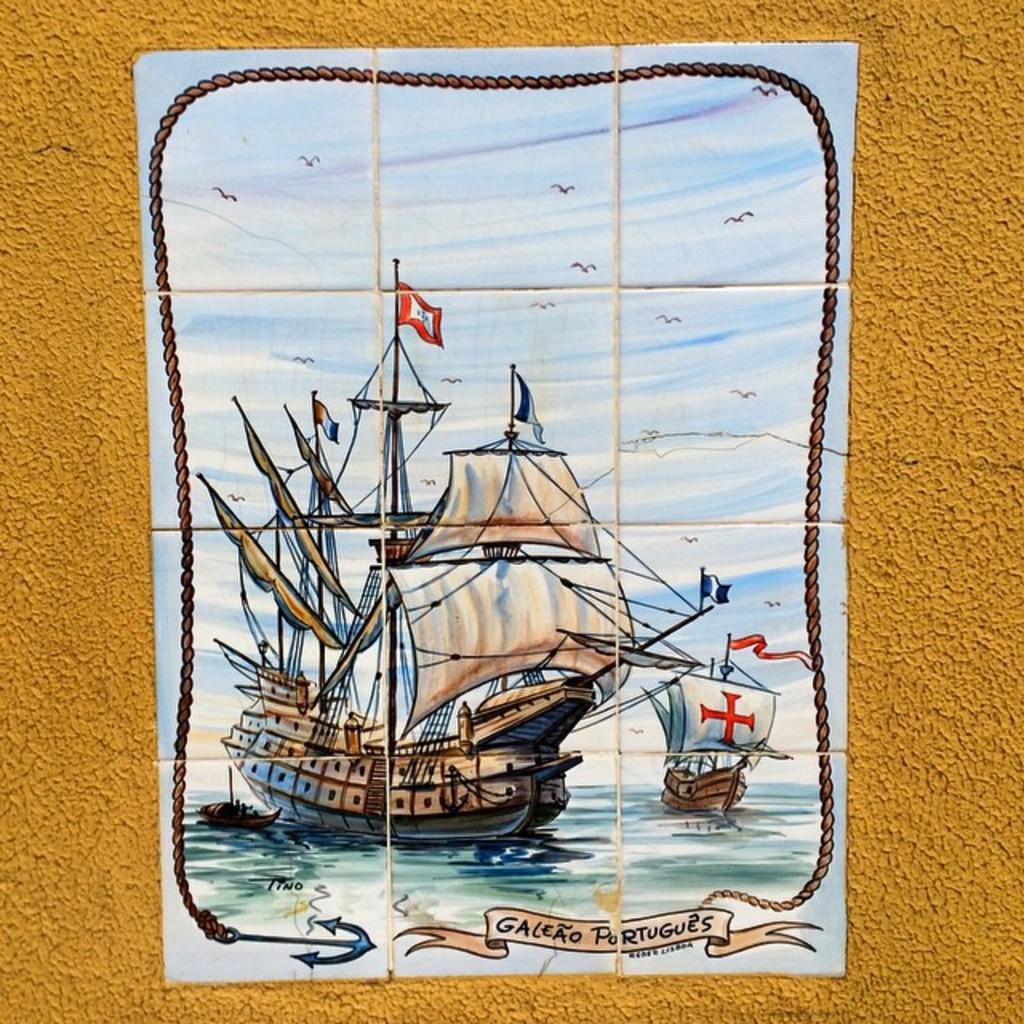What does the puzzle caption tell us?
Your answer should be very brief. Galeao portugues. Did tino paint and sign this above the anchor?
Your response must be concise. Yes. 